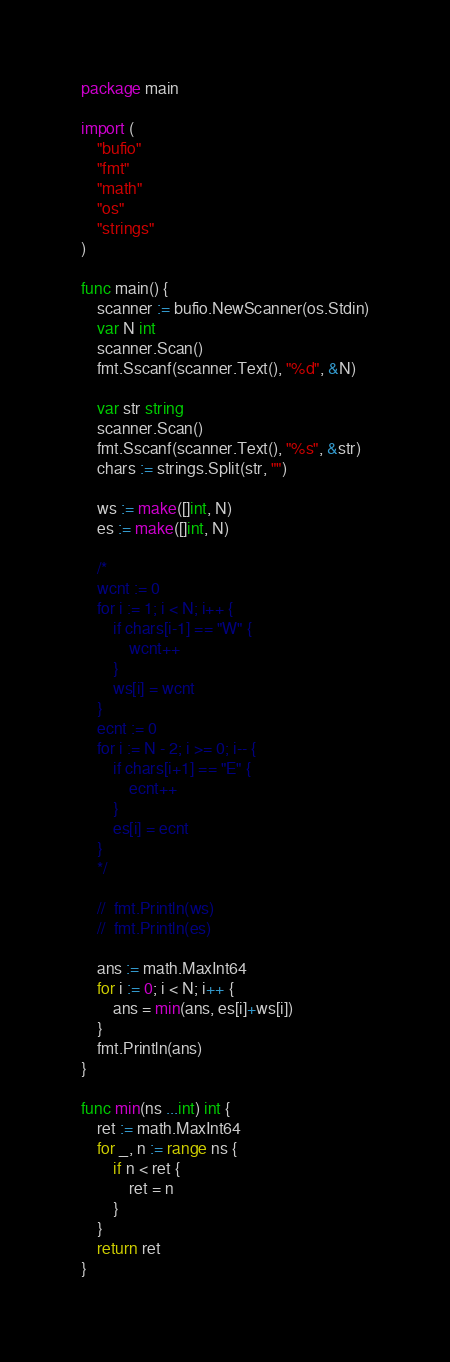<code> <loc_0><loc_0><loc_500><loc_500><_Go_>package main

import (
	"bufio"
	"fmt"
	"math"
	"os"
	"strings"
)

func main() {
	scanner := bufio.NewScanner(os.Stdin)
	var N int
	scanner.Scan()
	fmt.Sscanf(scanner.Text(), "%d", &N)

	var str string
	scanner.Scan()
	fmt.Sscanf(scanner.Text(), "%s", &str)
	chars := strings.Split(str, "")

	ws := make([]int, N)
	es := make([]int, N)

  	/*
	wcnt := 0
	for i := 1; i < N; i++ {
		if chars[i-1] == "W" {
			wcnt++
		}
		ws[i] = wcnt
	}
	ecnt := 0
	for i := N - 2; i >= 0; i-- {
		if chars[i+1] == "E" {
			ecnt++
		}
		es[i] = ecnt
	}
	*/

	//	fmt.Println(ws)
	//  fmt.Println(es)

	ans := math.MaxInt64
	for i := 0; i < N; i++ {
		ans = min(ans, es[i]+ws[i])
	}
	fmt.Println(ans)
}

func min(ns ...int) int {
	ret := math.MaxInt64
	for _, n := range ns {
		if n < ret {
			ret = n
		}
	}
	return ret
}
</code> 